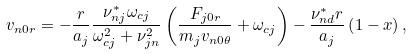Convert formula to latex. <formula><loc_0><loc_0><loc_500><loc_500>v _ { n 0 r } = - \frac { r } { a _ { j } } \frac { \nu _ { n j } ^ { * } \omega _ { c j } } { \omega _ { c j } ^ { 2 } + \nu _ { j n } ^ { 2 } } \left ( \frac { F _ { j 0 r } } { m _ { j } v _ { n 0 \theta } } + \omega _ { c j } \right ) - \frac { \nu _ { n d } ^ { * } r } { a _ { j } } \left ( 1 - x \right ) ,</formula> 